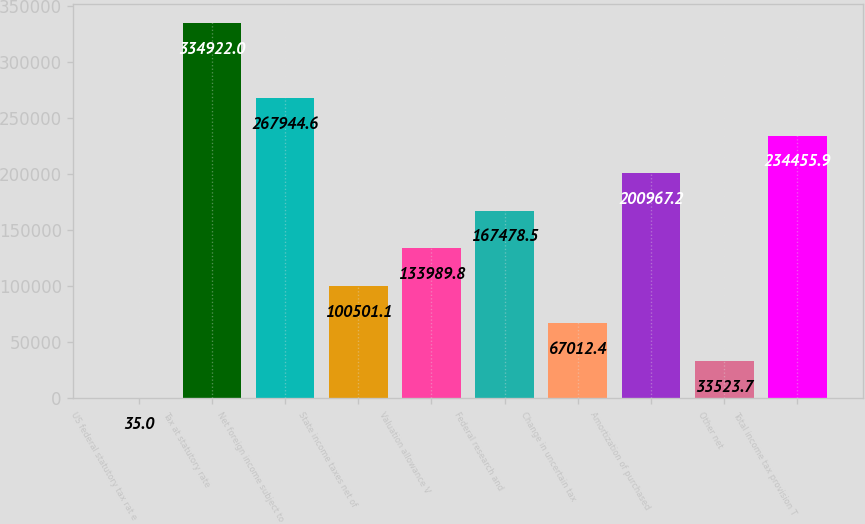<chart> <loc_0><loc_0><loc_500><loc_500><bar_chart><fcel>US federal statutory tax rat e<fcel>Tax at statutory rate<fcel>Net foreign income subject to<fcel>State income taxes net of<fcel>Valuation allowance V<fcel>Federal research and<fcel>Change in uncertain tax<fcel>Amortization of purchased<fcel>Other net<fcel>Total income tax provision T<nl><fcel>35<fcel>334922<fcel>267945<fcel>100501<fcel>133990<fcel>167478<fcel>67012.4<fcel>200967<fcel>33523.7<fcel>234456<nl></chart> 